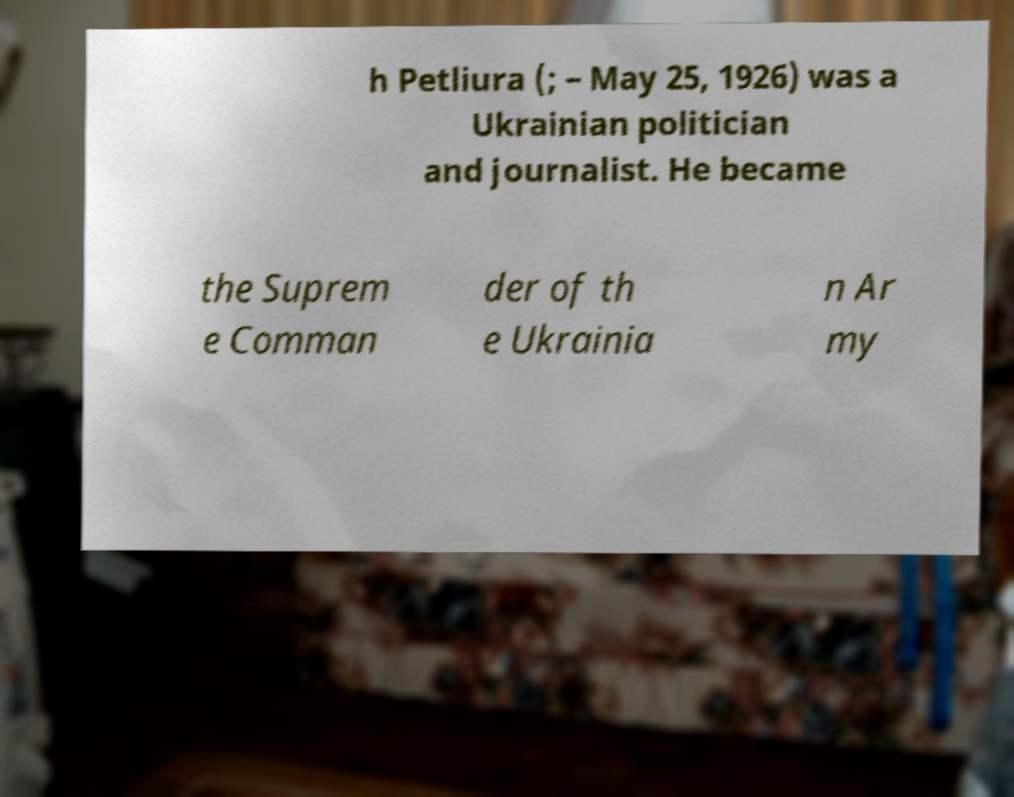For documentation purposes, I need the text within this image transcribed. Could you provide that? h Petliura (; – May 25, 1926) was a Ukrainian politician and journalist. He became the Suprem e Comman der of th e Ukrainia n Ar my 